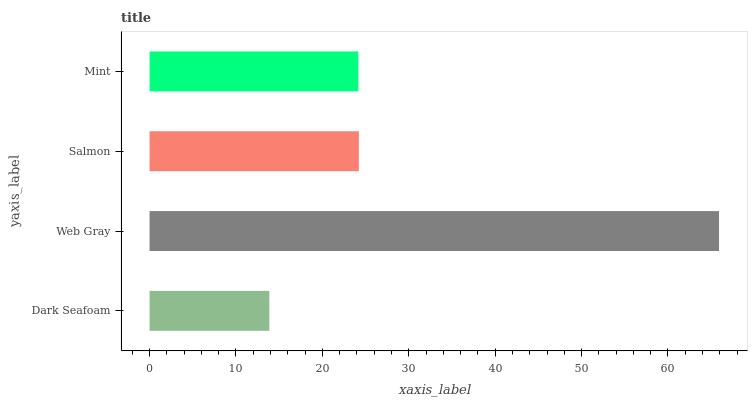Is Dark Seafoam the minimum?
Answer yes or no. Yes. Is Web Gray the maximum?
Answer yes or no. Yes. Is Salmon the minimum?
Answer yes or no. No. Is Salmon the maximum?
Answer yes or no. No. Is Web Gray greater than Salmon?
Answer yes or no. Yes. Is Salmon less than Web Gray?
Answer yes or no. Yes. Is Salmon greater than Web Gray?
Answer yes or no. No. Is Web Gray less than Salmon?
Answer yes or no. No. Is Salmon the high median?
Answer yes or no. Yes. Is Mint the low median?
Answer yes or no. Yes. Is Web Gray the high median?
Answer yes or no. No. Is Dark Seafoam the low median?
Answer yes or no. No. 